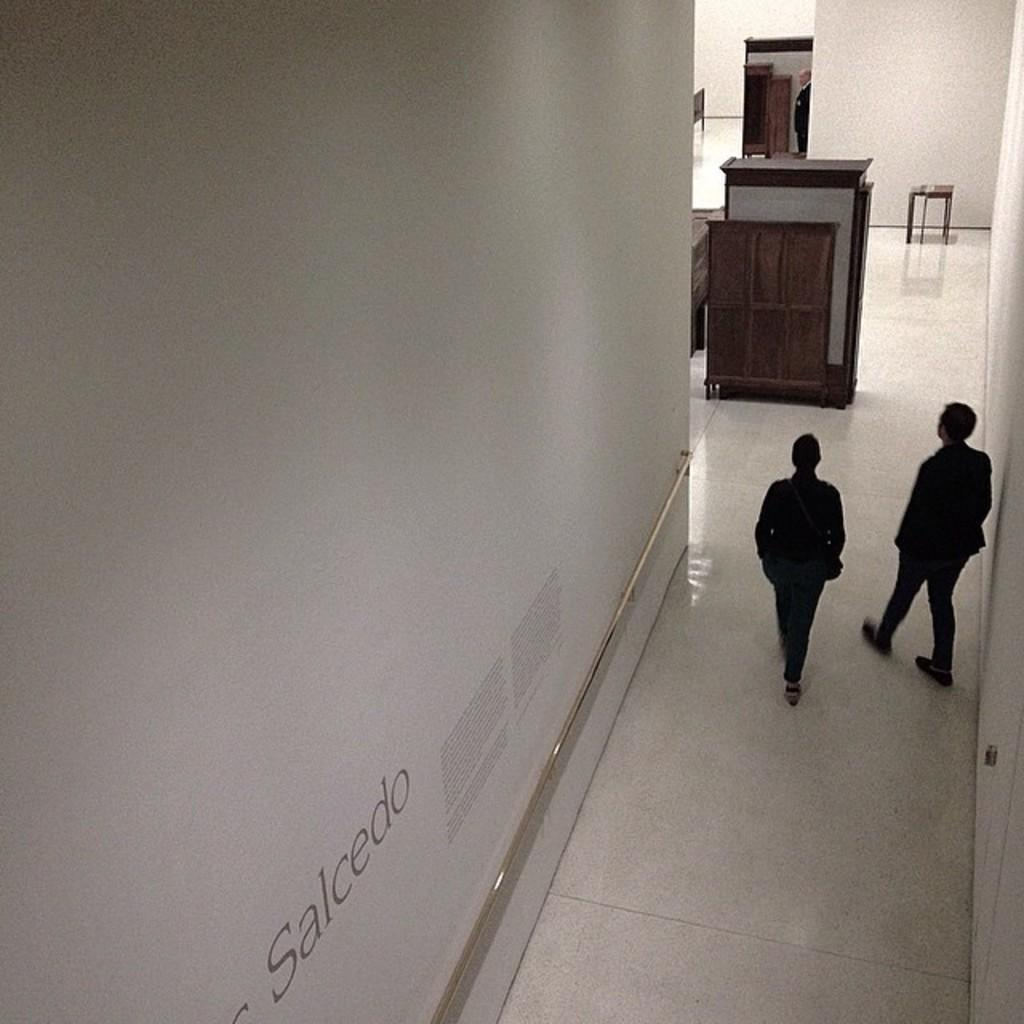What is present on the wall in the image? There is text on the wall in the image. Who or what can be seen in the image besides the wall? There are people and a table in the image. What might be used for placing items in the image? There is a table in the image for placing items. What can be found on the floor in the image? There are objects on the floor in the image. What type of tramp is visible in the image? There is no tramp present in the image. What kind of root can be seen growing on the wall in the image? There is no root growing on the wall in the image. 